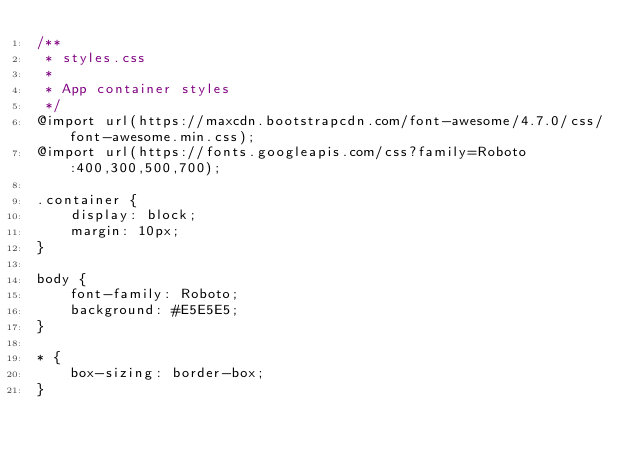Convert code to text. <code><loc_0><loc_0><loc_500><loc_500><_CSS_>/**
 * styles.css
 *
 * App container styles
 */
@import url(https://maxcdn.bootstrapcdn.com/font-awesome/4.7.0/css/font-awesome.min.css);
@import url(https://fonts.googleapis.com/css?family=Roboto:400,300,500,700);

.container {
    display: block;
    margin: 10px;
}

body {
    font-family: Roboto;
    background: #E5E5E5;
}

* {
    box-sizing: border-box;
}</code> 